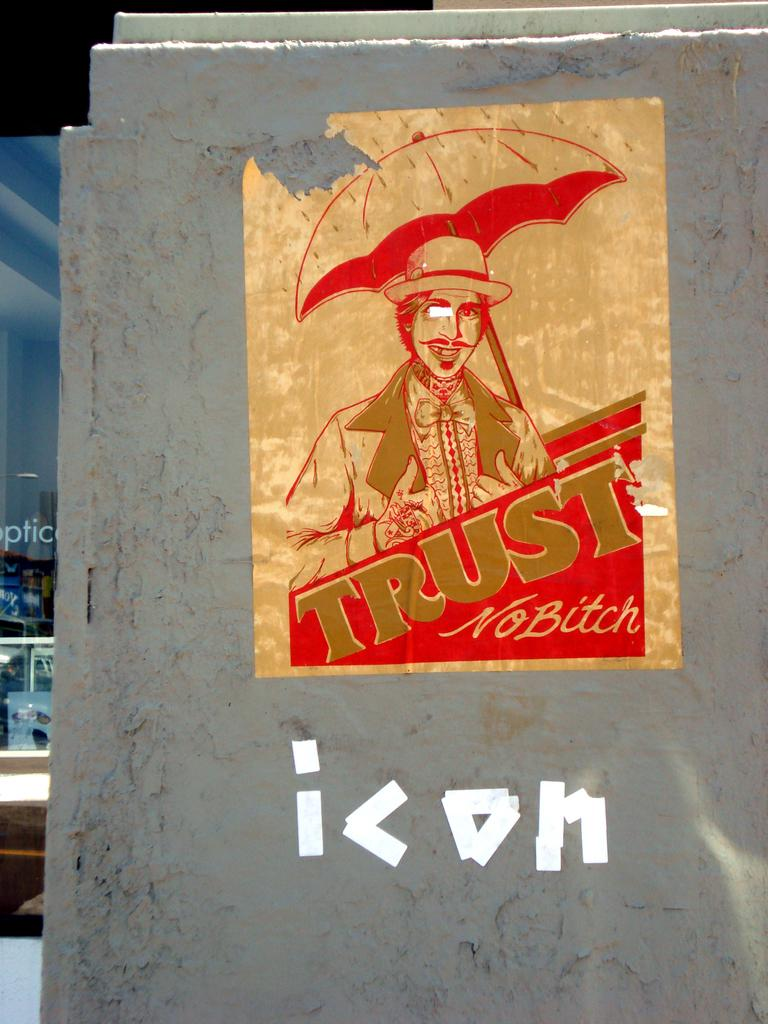<image>
Give a short and clear explanation of the subsequent image. The poster features a man carrying an umbrella and the words Trust No Bitch. 